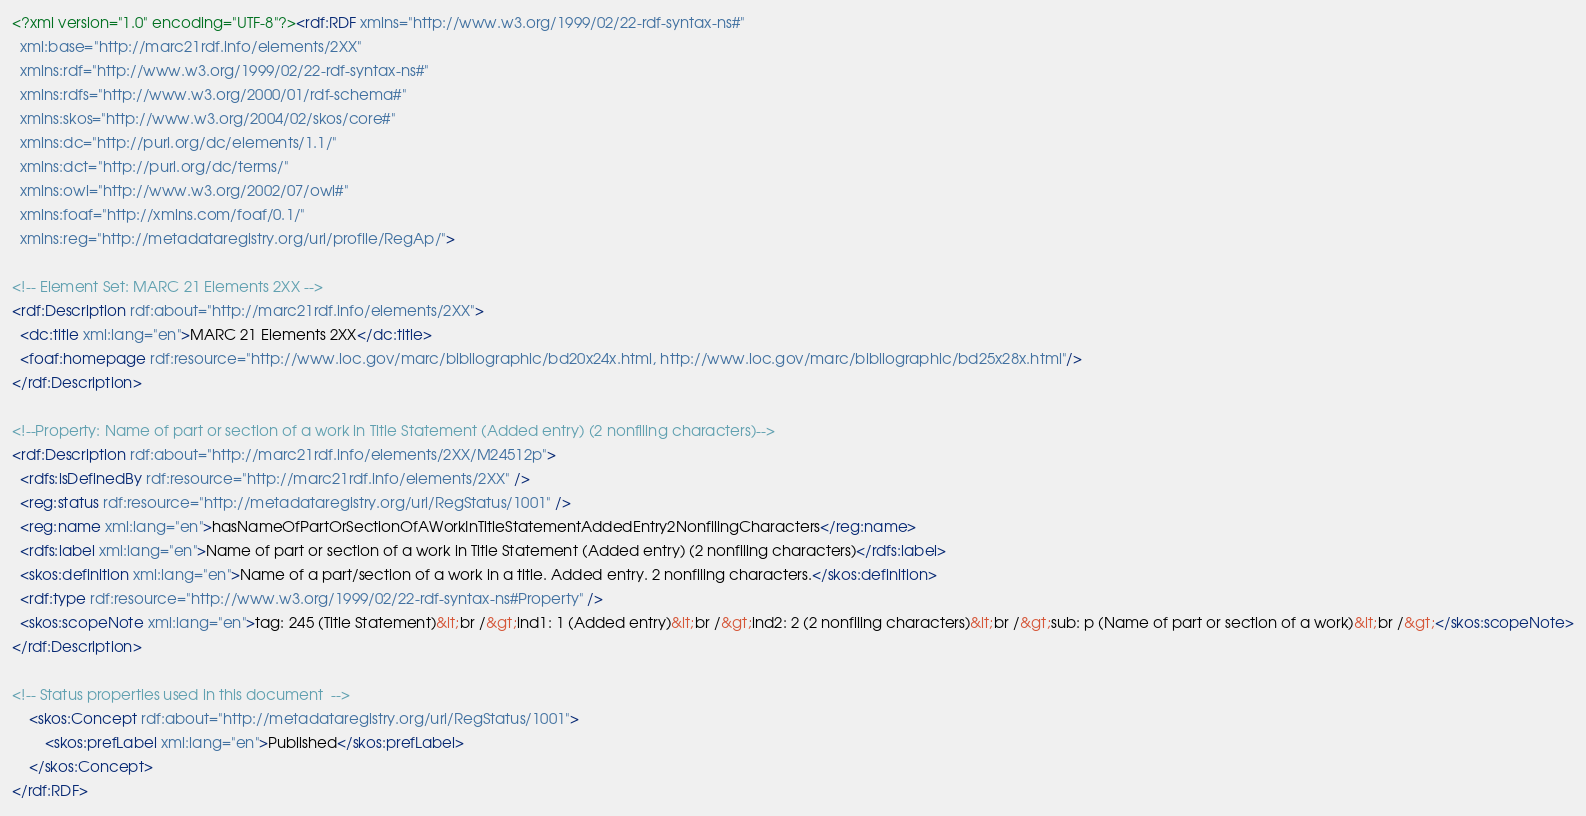<code> <loc_0><loc_0><loc_500><loc_500><_XML_><?xml version="1.0" encoding="UTF-8"?><rdf:RDF xmlns="http://www.w3.org/1999/02/22-rdf-syntax-ns#"
  xml:base="http://marc21rdf.info/elements/2XX"
  xmlns:rdf="http://www.w3.org/1999/02/22-rdf-syntax-ns#"
  xmlns:rdfs="http://www.w3.org/2000/01/rdf-schema#"
  xmlns:skos="http://www.w3.org/2004/02/skos/core#"
  xmlns:dc="http://purl.org/dc/elements/1.1/"
  xmlns:dct="http://purl.org/dc/terms/"
  xmlns:owl="http://www.w3.org/2002/07/owl#"
  xmlns:foaf="http://xmlns.com/foaf/0.1/"
  xmlns:reg="http://metadataregistry.org/uri/profile/RegAp/">

<!-- Element Set: MARC 21 Elements 2XX -->
<rdf:Description rdf:about="http://marc21rdf.info/elements/2XX">
  <dc:title xml:lang="en">MARC 21 Elements 2XX</dc:title>
  <foaf:homepage rdf:resource="http://www.loc.gov/marc/bibliographic/bd20x24x.html, http://www.loc.gov/marc/bibliographic/bd25x28x.html"/>
</rdf:Description>

<!--Property: Name of part or section of a work in Title Statement (Added entry) (2 nonfiling characters)-->
<rdf:Description rdf:about="http://marc21rdf.info/elements/2XX/M24512p">
  <rdfs:isDefinedBy rdf:resource="http://marc21rdf.info/elements/2XX" />
  <reg:status rdf:resource="http://metadataregistry.org/uri/RegStatus/1001" />
  <reg:name xml:lang="en">hasNameOfPartOrSectionOfAWorkInTitleStatementAddedEntry2NonfilingCharacters</reg:name>
  <rdfs:label xml:lang="en">Name of part or section of a work in Title Statement (Added entry) (2 nonfiling characters)</rdfs:label>
  <skos:definition xml:lang="en">Name of a part/section of a work in a title. Added entry. 2 nonfiling characters.</skos:definition>
  <rdf:type rdf:resource="http://www.w3.org/1999/02/22-rdf-syntax-ns#Property" />
  <skos:scopeNote xml:lang="en">tag: 245 (Title Statement)&lt;br /&gt;ind1: 1 (Added entry)&lt;br /&gt;ind2: 2 (2 nonfiling characters)&lt;br /&gt;sub: p (Name of part or section of a work)&lt;br /&gt;</skos:scopeNote>
</rdf:Description>

<!-- Status properties used in this document  -->
    <skos:Concept rdf:about="http://metadataregistry.org/uri/RegStatus/1001">
        <skos:prefLabel xml:lang="en">Published</skos:prefLabel>
    </skos:Concept>
</rdf:RDF></code> 